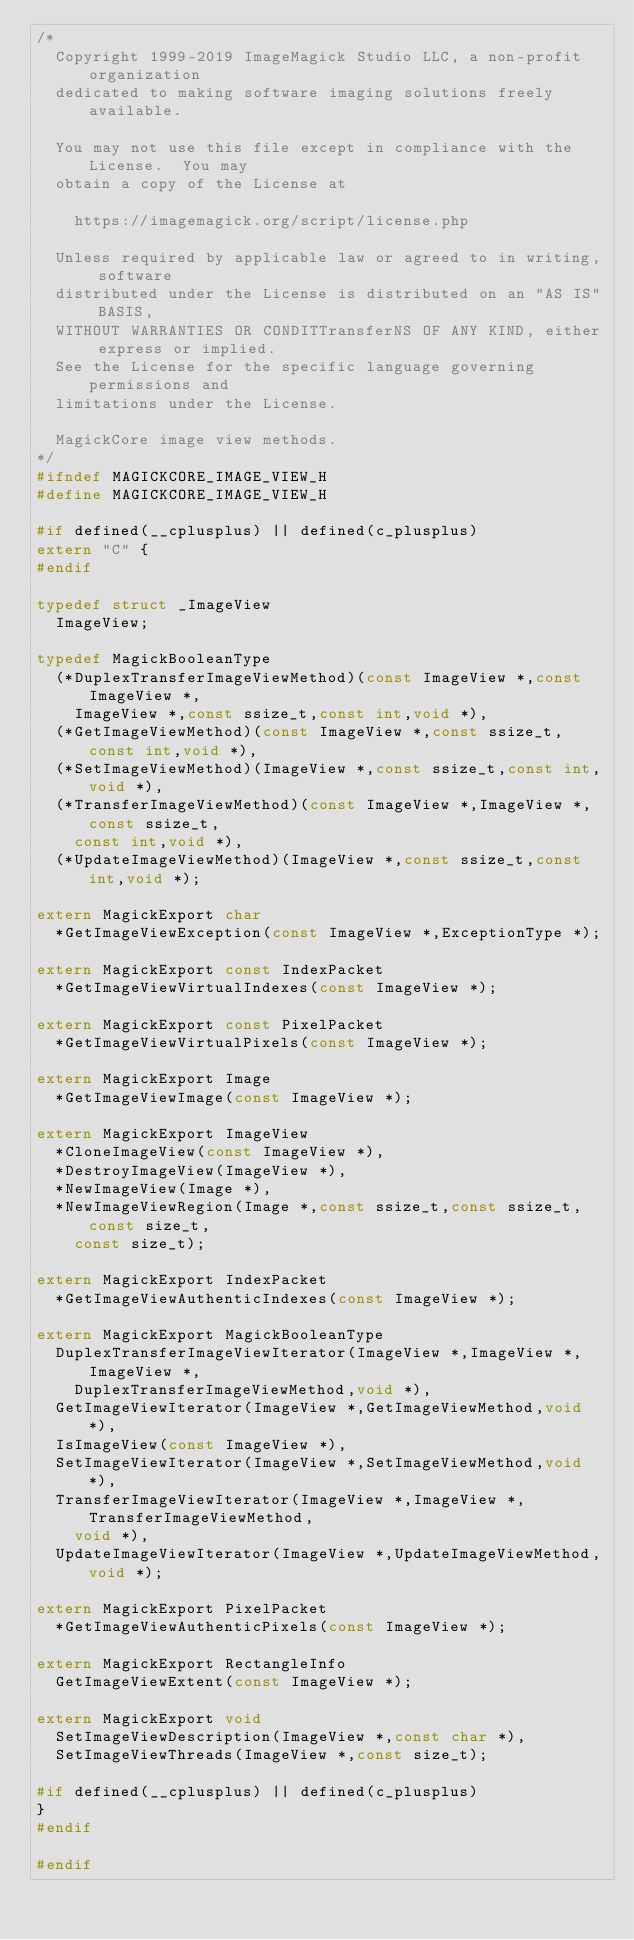Convert code to text. <code><loc_0><loc_0><loc_500><loc_500><_C_>/*
  Copyright 1999-2019 ImageMagick Studio LLC, a non-profit organization
  dedicated to making software imaging solutions freely available.
  
  You may not use this file except in compliance with the License.  You may
  obtain a copy of the License at
  
    https://imagemagick.org/script/license.php
  
  Unless required by applicable law or agreed to in writing, software
  distributed under the License is distributed on an "AS IS" BASIS,
  WITHOUT WARRANTIES OR CONDITTransferNS OF ANY KIND, either express or implied.
  See the License for the specific language governing permissions and
  limitations under the License.

  MagickCore image view methods.
*/
#ifndef MAGICKCORE_IMAGE_VIEW_H
#define MAGICKCORE_IMAGE_VIEW_H

#if defined(__cplusplus) || defined(c_plusplus)
extern "C" {
#endif

typedef struct _ImageView
  ImageView;

typedef MagickBooleanType
  (*DuplexTransferImageViewMethod)(const ImageView *,const ImageView *,
    ImageView *,const ssize_t,const int,void *),
  (*GetImageViewMethod)(const ImageView *,const ssize_t,const int,void *),
  (*SetImageViewMethod)(ImageView *,const ssize_t,const int,void *),
  (*TransferImageViewMethod)(const ImageView *,ImageView *,const ssize_t,
    const int,void *),
  (*UpdateImageViewMethod)(ImageView *,const ssize_t,const int,void *);

extern MagickExport char
  *GetImageViewException(const ImageView *,ExceptionType *);

extern MagickExport const IndexPacket
  *GetImageViewVirtualIndexes(const ImageView *);

extern MagickExport const PixelPacket
  *GetImageViewVirtualPixels(const ImageView *);

extern MagickExport Image
  *GetImageViewImage(const ImageView *);

extern MagickExport ImageView
  *CloneImageView(const ImageView *),
  *DestroyImageView(ImageView *),
  *NewImageView(Image *),
  *NewImageViewRegion(Image *,const ssize_t,const ssize_t,const size_t,
    const size_t);

extern MagickExport IndexPacket
  *GetImageViewAuthenticIndexes(const ImageView *);

extern MagickExport MagickBooleanType
  DuplexTransferImageViewIterator(ImageView *,ImageView *,ImageView *,
    DuplexTransferImageViewMethod,void *),
  GetImageViewIterator(ImageView *,GetImageViewMethod,void *),
  IsImageView(const ImageView *),
  SetImageViewIterator(ImageView *,SetImageViewMethod,void *),
  TransferImageViewIterator(ImageView *,ImageView *,TransferImageViewMethod,
    void *),
  UpdateImageViewIterator(ImageView *,UpdateImageViewMethod,void *);

extern MagickExport PixelPacket
  *GetImageViewAuthenticPixels(const ImageView *);

extern MagickExport RectangleInfo
  GetImageViewExtent(const ImageView *);

extern MagickExport void
  SetImageViewDescription(ImageView *,const char *),
  SetImageViewThreads(ImageView *,const size_t);

#if defined(__cplusplus) || defined(c_plusplus)
}
#endif

#endif
</code> 